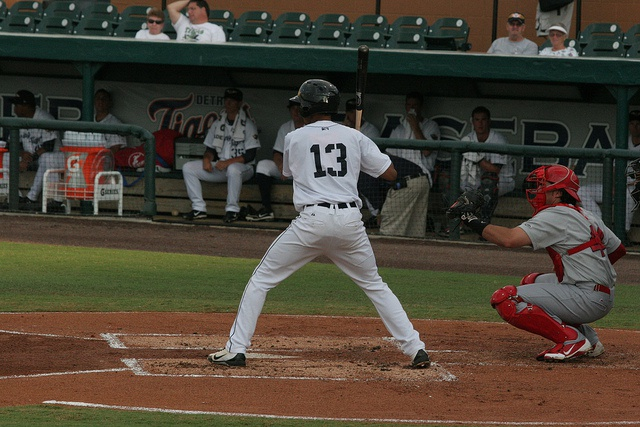Describe the objects in this image and their specific colors. I can see people in darkgreen, darkgray, gray, and black tones, people in darkgreen, gray, black, and maroon tones, people in darkgreen, black, gray, darkgray, and maroon tones, people in darkgreen, black, gray, and maroon tones, and people in darkgreen, black, gray, and purple tones in this image. 